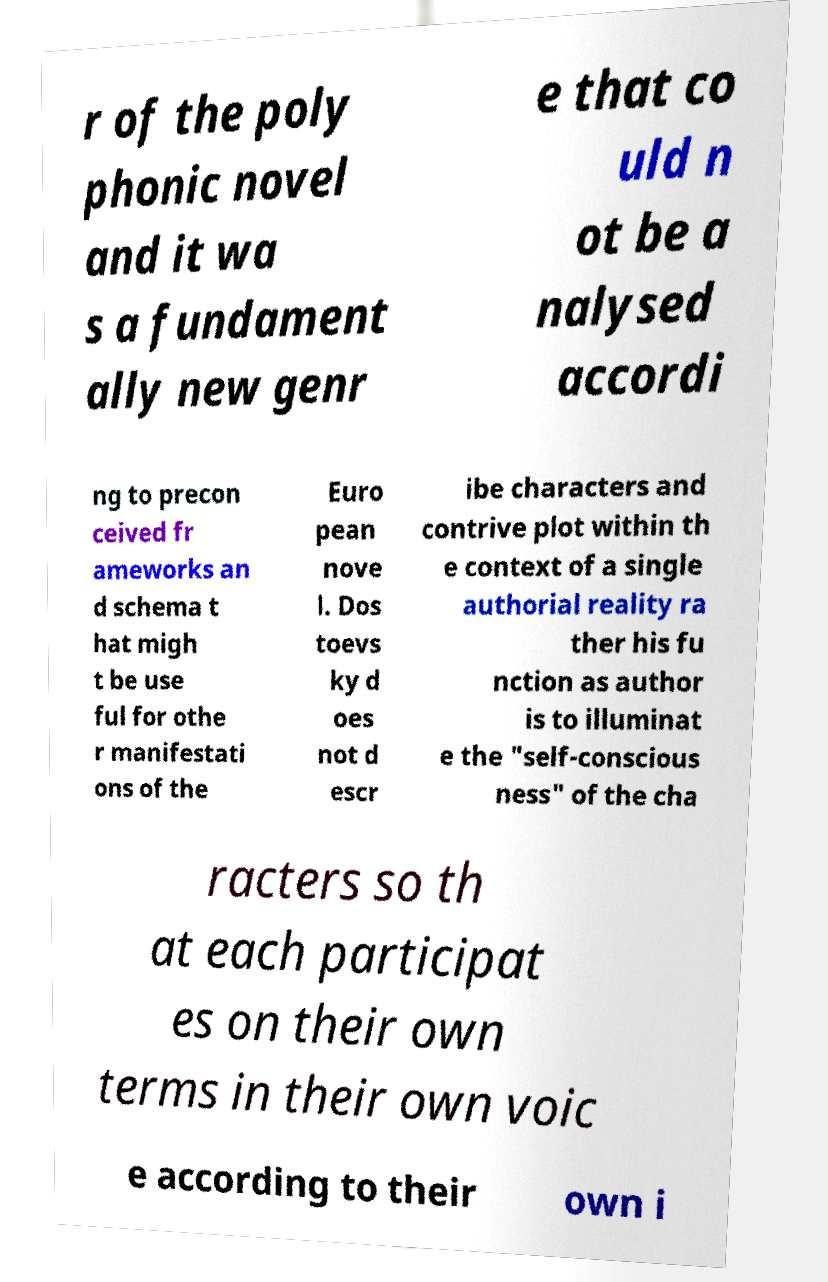Could you assist in decoding the text presented in this image and type it out clearly? r of the poly phonic novel and it wa s a fundament ally new genr e that co uld n ot be a nalysed accordi ng to precon ceived fr ameworks an d schema t hat migh t be use ful for othe r manifestati ons of the Euro pean nove l. Dos toevs ky d oes not d escr ibe characters and contrive plot within th e context of a single authorial reality ra ther his fu nction as author is to illuminat e the "self-conscious ness" of the cha racters so th at each participat es on their own terms in their own voic e according to their own i 